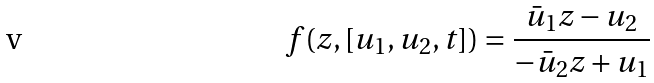<formula> <loc_0><loc_0><loc_500><loc_500>f ( z , [ u _ { 1 } , u _ { 2 } , t ] ) = \frac { \bar { u } _ { 1 } z - u _ { 2 } } { - \bar { u } _ { 2 } z + u _ { 1 } }</formula> 